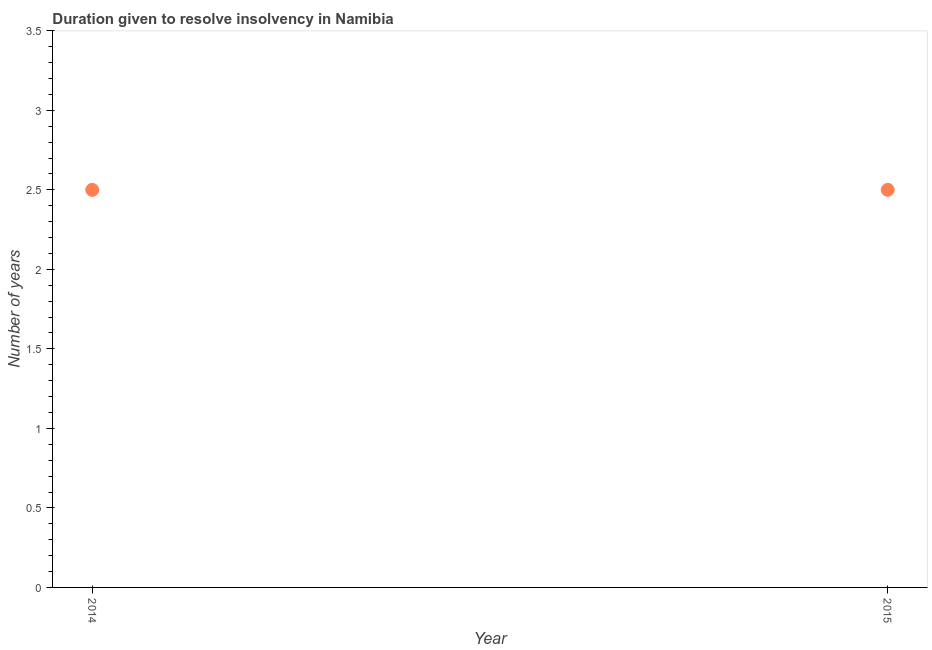In which year was the number of years to resolve insolvency maximum?
Keep it short and to the point. 2014. In which year was the number of years to resolve insolvency minimum?
Provide a short and direct response. 2014. What is the median number of years to resolve insolvency?
Your response must be concise. 2.5. Do a majority of the years between 2015 and 2014 (inclusive) have number of years to resolve insolvency greater than 0.5 ?
Ensure brevity in your answer.  No. In how many years, is the number of years to resolve insolvency greater than the average number of years to resolve insolvency taken over all years?
Ensure brevity in your answer.  0. How many dotlines are there?
Offer a very short reply. 1. What is the difference between two consecutive major ticks on the Y-axis?
Your answer should be compact. 0.5. Are the values on the major ticks of Y-axis written in scientific E-notation?
Offer a very short reply. No. Does the graph contain any zero values?
Ensure brevity in your answer.  No. Does the graph contain grids?
Ensure brevity in your answer.  No. What is the title of the graph?
Provide a short and direct response. Duration given to resolve insolvency in Namibia. What is the label or title of the X-axis?
Offer a terse response. Year. What is the label or title of the Y-axis?
Your response must be concise. Number of years. What is the difference between the Number of years in 2014 and 2015?
Your answer should be very brief. 0. What is the ratio of the Number of years in 2014 to that in 2015?
Provide a succinct answer. 1. 